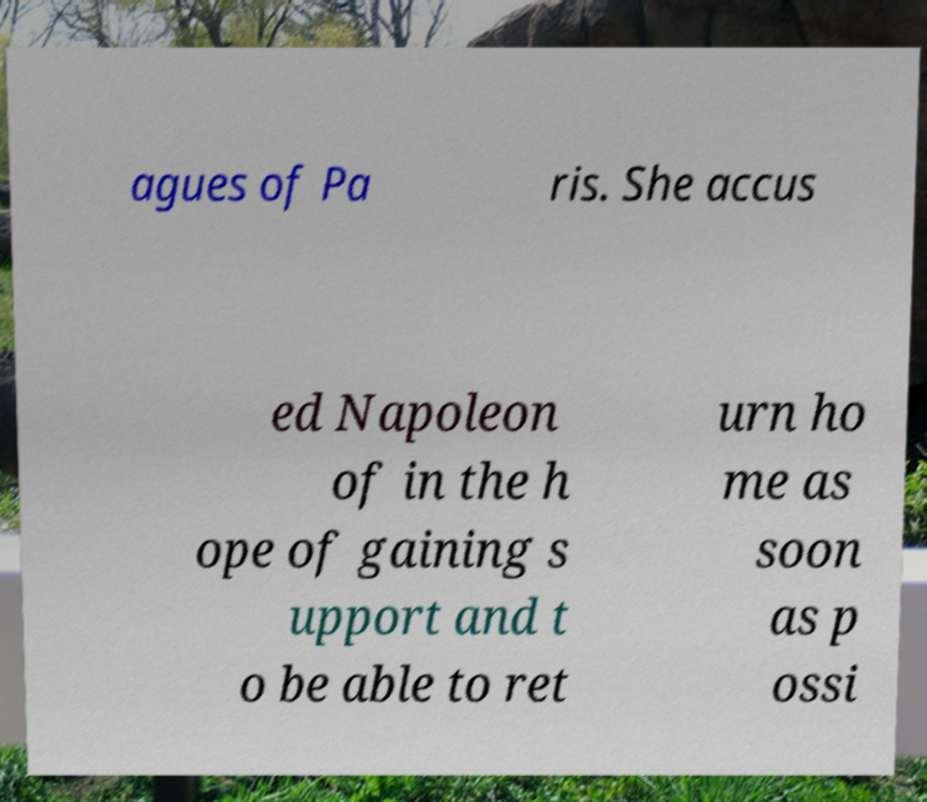There's text embedded in this image that I need extracted. Can you transcribe it verbatim? agues of Pa ris. She accus ed Napoleon of in the h ope of gaining s upport and t o be able to ret urn ho me as soon as p ossi 